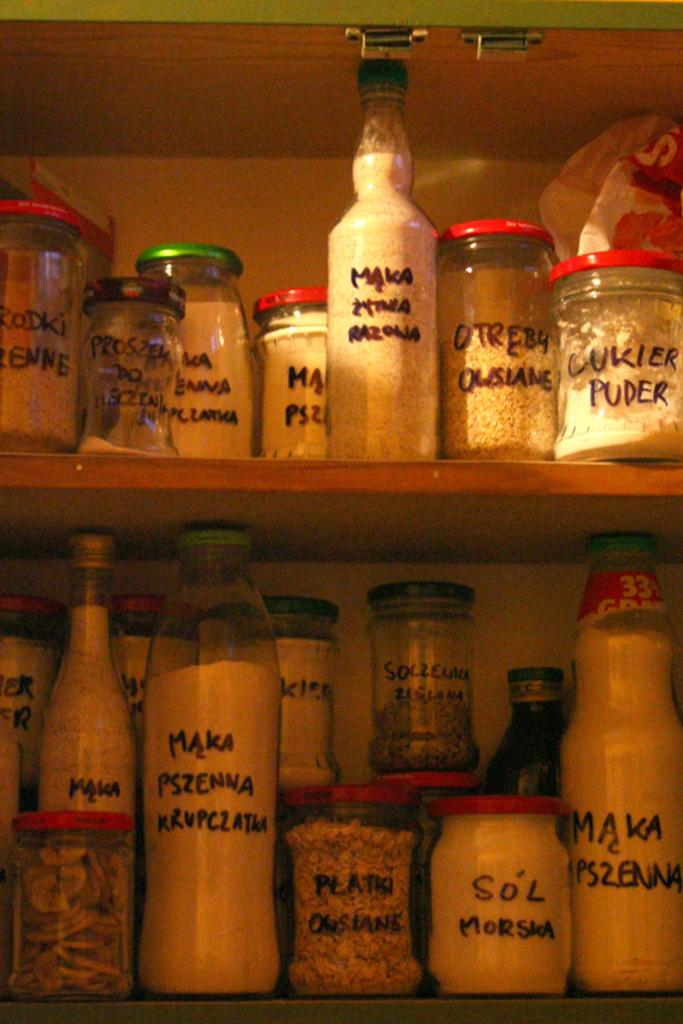Provide a one-sentence caption for the provided image. Jars filled with things like Lukier Puder line some pantry shelves. 